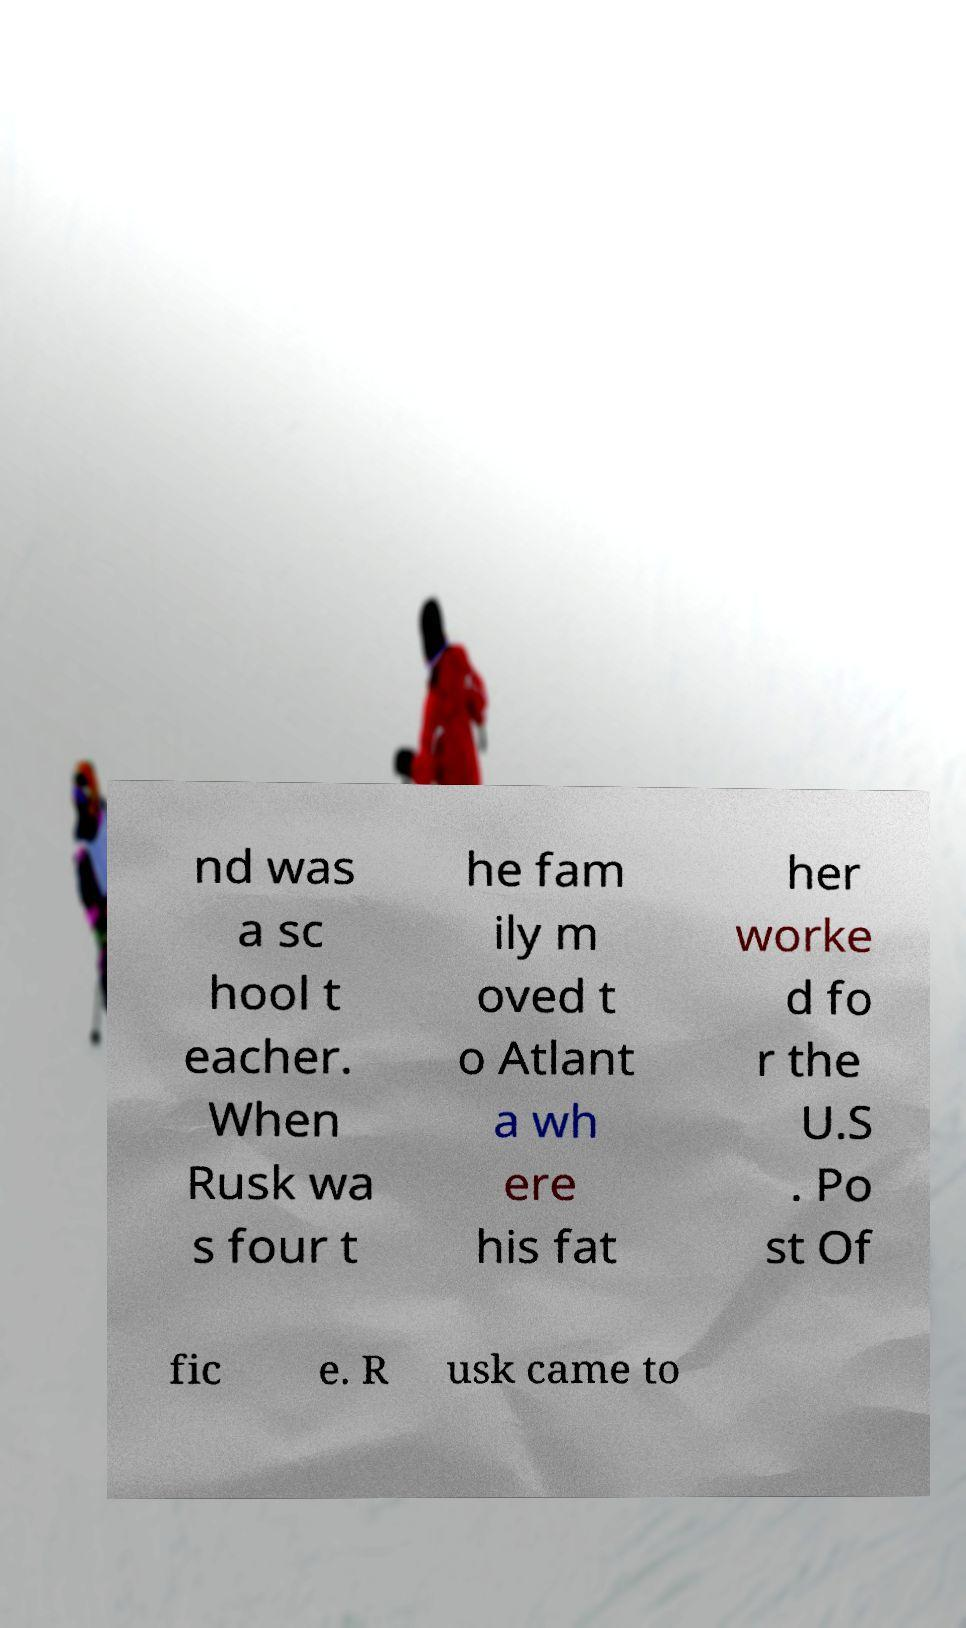Can you read and provide the text displayed in the image?This photo seems to have some interesting text. Can you extract and type it out for me? nd was a sc hool t eacher. When Rusk wa s four t he fam ily m oved t o Atlant a wh ere his fat her worke d fo r the U.S . Po st Of fic e. R usk came to 